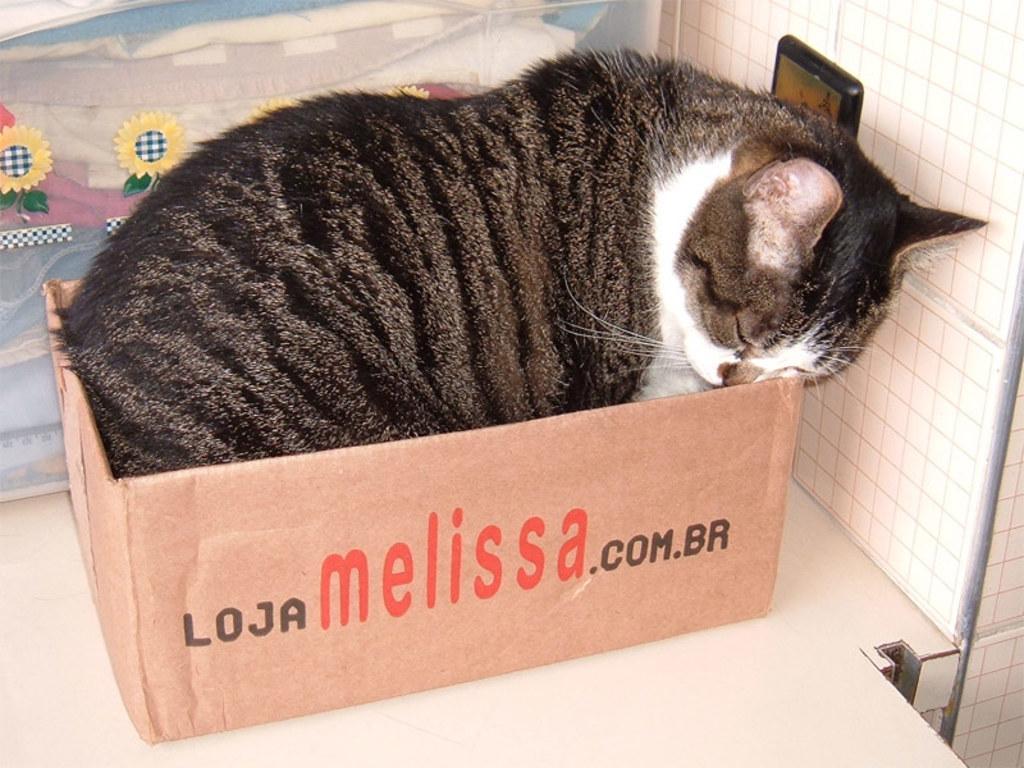How would you summarize this image in a sentence or two? The picture consists of a cat in a box. The box is on the desk. At the top there is a poster. On the right there is light attached to the wall. 